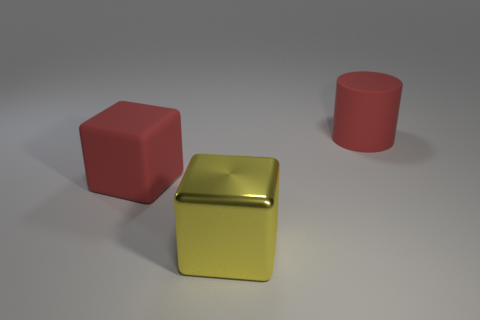Is the yellow shiny object the same size as the red cube?
Your answer should be compact. Yes. How many large things are both behind the yellow metal cube and right of the red cube?
Provide a short and direct response. 1. What number of green objects are either shiny blocks or matte things?
Keep it short and to the point. 0. How many metallic objects are either yellow blocks or red blocks?
Offer a very short reply. 1. Is there a matte cylinder?
Ensure brevity in your answer.  Yes. What number of yellow blocks are behind the large matte object that is in front of the red matte thing that is right of the matte cube?
Provide a short and direct response. 0. What is the large thing that is in front of the big rubber cylinder and on the right side of the big matte cube made of?
Your answer should be very brief. Metal. The object that is in front of the big matte cylinder and on the right side of the red matte cube is what color?
Your answer should be compact. Yellow. Is there any other thing that has the same color as the large rubber cylinder?
Ensure brevity in your answer.  Yes. There is a large matte object that is on the right side of the block right of the red rubber thing to the left of the red cylinder; what is its shape?
Provide a succinct answer. Cylinder. 